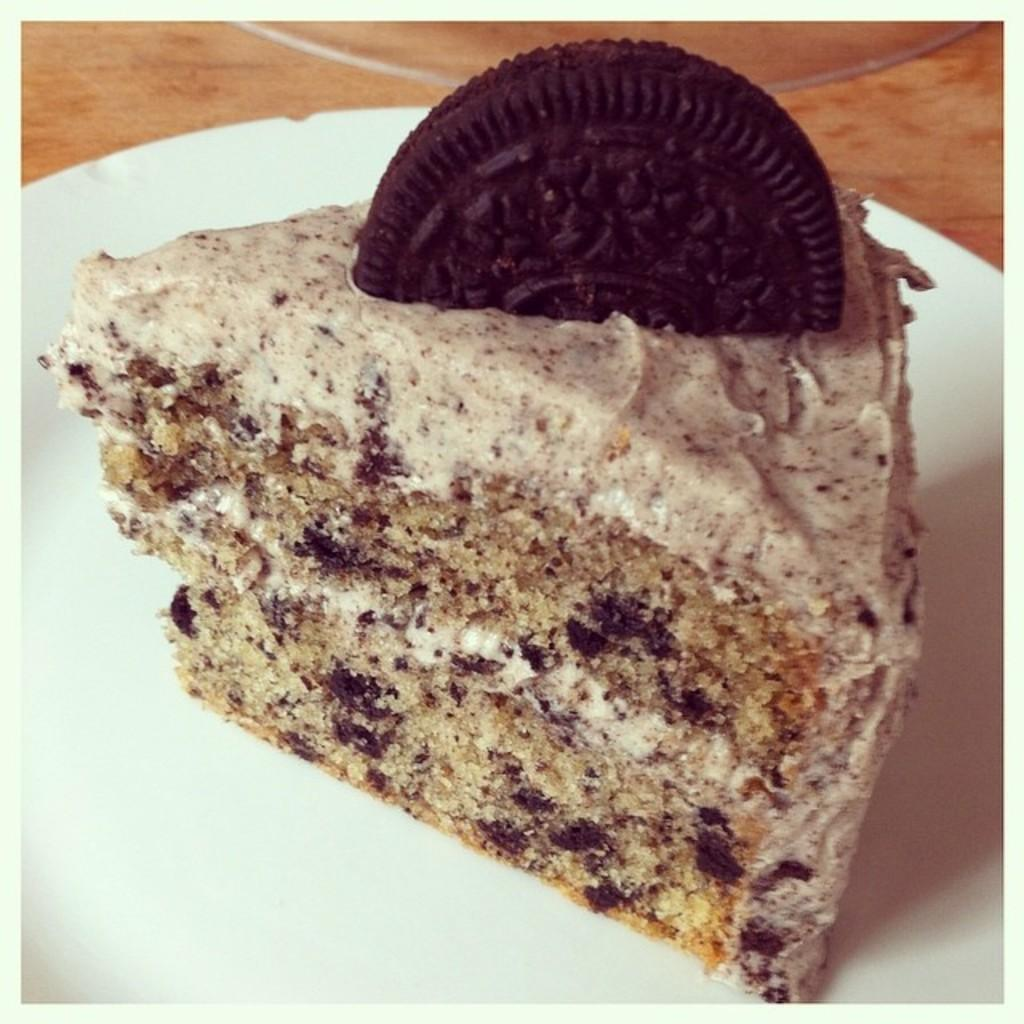What is on the white plate in the image? There is food on a white plate in the image. Can you describe the object at the back of the image? Unfortunately, the provided facts do not give enough information to describe the object at the back of the image. What is visible at the bottom of the image? There is a table visible at the bottom of the image. What type of powder is being used to clean the airplane in the image? There is no airplane present in the image, and therefore no cleaning activity involving powder can be observed. 